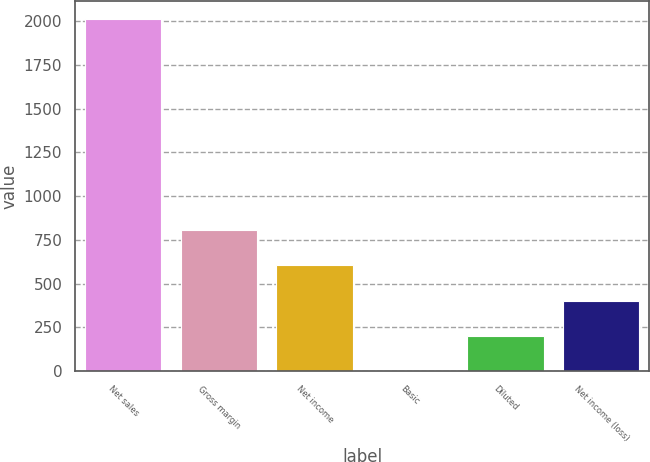Convert chart. <chart><loc_0><loc_0><loc_500><loc_500><bar_chart><fcel>Net sales<fcel>Gross margin<fcel>Net income<fcel>Basic<fcel>Diluted<fcel>Net income (loss)<nl><fcel>2014<fcel>805.68<fcel>604.3<fcel>0.16<fcel>201.54<fcel>402.92<nl></chart> 